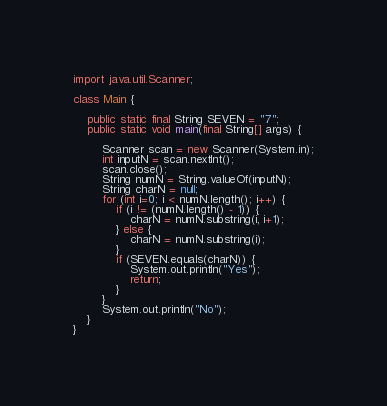<code> <loc_0><loc_0><loc_500><loc_500><_Java_>import java.util.Scanner;

class Main {

	public static final String SEVEN = "7";
	public static void main(final String[] args) {

		Scanner scan = new Scanner(System.in);
		int inputN = scan.nextInt();
		scan.close();
		String numN = String.valueOf(inputN);
		String charN = null;
		for (int i=0; i < numN.length(); i++) {
			if (i != (numN.length() - 1)) {
				charN = numN.substring(i, i+1);
			} else {
				charN = numN.substring(i);
			}
			if (SEVEN.equals(charN)) {
				System.out.println("Yes");
				return;
			}
		} 
		System.out.println("No");
	}
}</code> 